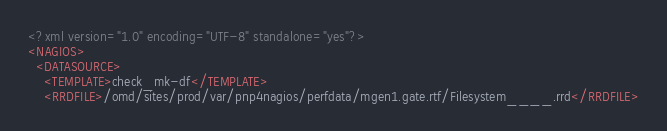<code> <loc_0><loc_0><loc_500><loc_500><_XML_><?xml version="1.0" encoding="UTF-8" standalone="yes"?>
<NAGIOS>
  <DATASOURCE>
    <TEMPLATE>check_mk-df</TEMPLATE>
    <RRDFILE>/omd/sites/prod/var/pnp4nagios/perfdata/mgen1.gate.rtf/Filesystem____.rrd</RRDFILE></code> 